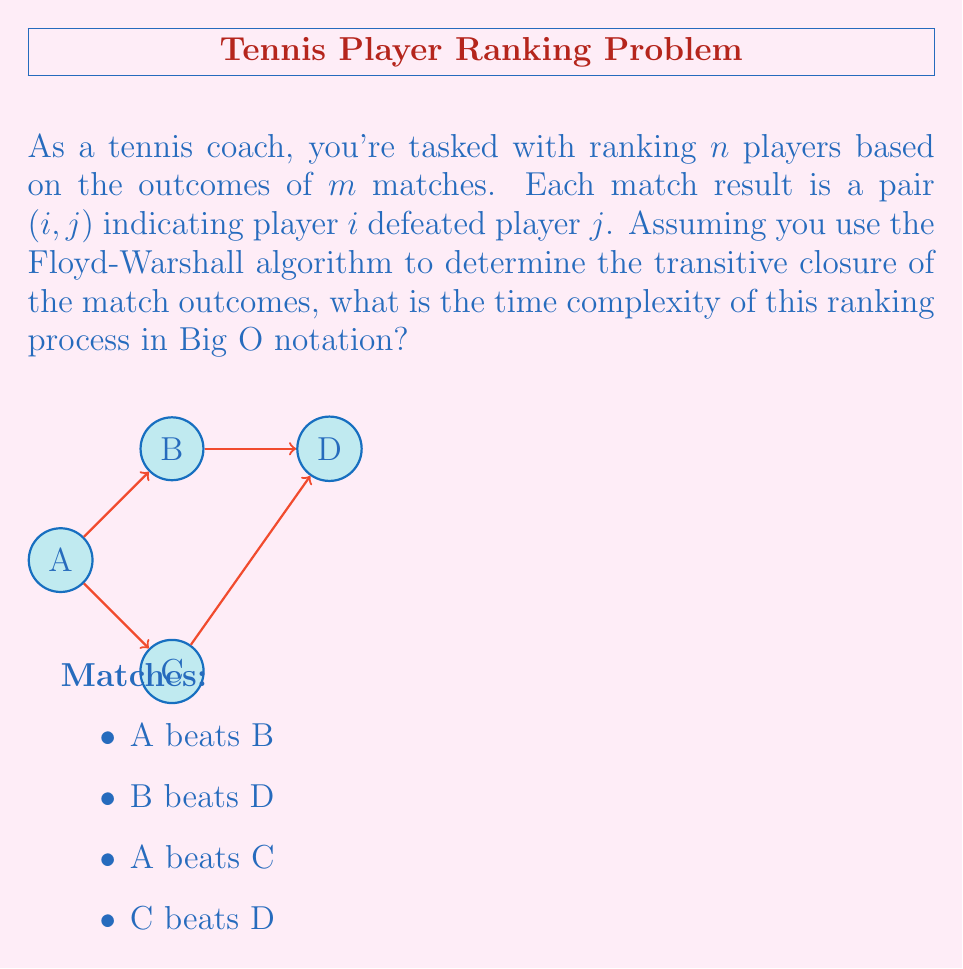Can you solve this math problem? Let's break this down step-by-step:

1) The Floyd-Warshall algorithm is used to find the shortest paths between all pairs of vertices in a weighted graph. In our case, we're using it to find the transitive closure of the match outcomes.

2) The algorithm works by considering each vertex as an intermediate vertex between every pair of vertices. It updates the shortest path if going through the intermediate vertex results in a shorter path.

3) The time complexity of the Floyd-Warshall algorithm is $O(V^3)$, where $V$ is the number of vertices in the graph.

4) In our case, the vertices represent players, so $V = n$.

5) The algorithm uses a 3-nested loop structure:
   ```
   for k = 1 to n
       for i = 1 to n
           for j = 1 to n
               if graph[i][j] > graph[i][k] + graph[k][j]
                   graph[i][j] = graph[i][k] + graph[k][j]
   ```

6) Each of these loops runs $n$ times, resulting in $n^3$ operations.

7) The initial step of creating the graph from the match outcomes takes $O(m)$ time, where $m$ is the number of matches.

8) However, as $n^3$ grows faster than $m$ (since $m$ is at most $\frac{n(n-1)}{2}$ for a complete tournament), the $O(m)$ term becomes insignificant for large $n$.

Therefore, the overall time complexity of this ranking process is $O(n^3)$.
Answer: $O(n^3)$ 